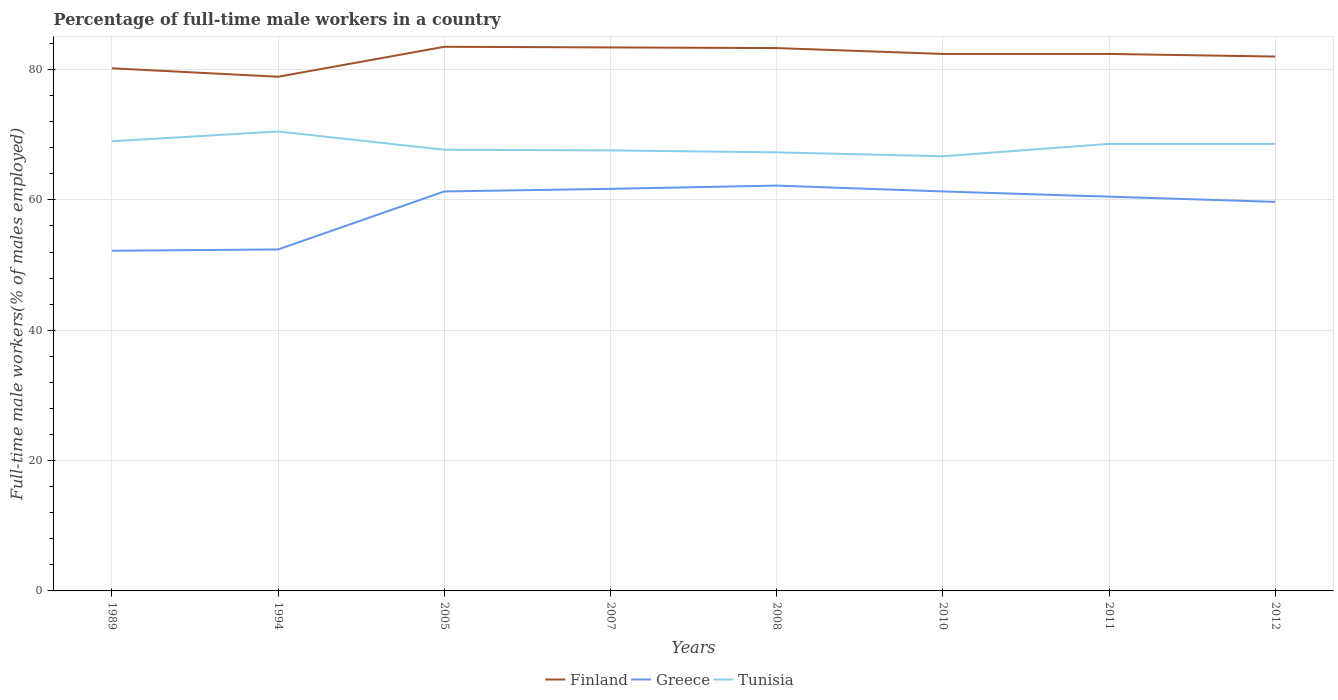Is the number of lines equal to the number of legend labels?
Your answer should be compact. Yes. Across all years, what is the maximum percentage of full-time male workers in Finland?
Give a very brief answer. 78.9. In which year was the percentage of full-time male workers in Tunisia maximum?
Offer a very short reply. 2010. What is the total percentage of full-time male workers in Greece in the graph?
Your answer should be very brief. 0. What is the difference between the highest and the second highest percentage of full-time male workers in Tunisia?
Make the answer very short. 3.8. What is the difference between the highest and the lowest percentage of full-time male workers in Finland?
Provide a succinct answer. 5. How many lines are there?
Ensure brevity in your answer.  3. Are the values on the major ticks of Y-axis written in scientific E-notation?
Offer a terse response. No. Does the graph contain grids?
Make the answer very short. Yes. How many legend labels are there?
Provide a succinct answer. 3. What is the title of the graph?
Your response must be concise. Percentage of full-time male workers in a country. What is the label or title of the Y-axis?
Offer a terse response. Full-time male workers(% of males employed). What is the Full-time male workers(% of males employed) in Finland in 1989?
Provide a succinct answer. 80.2. What is the Full-time male workers(% of males employed) of Greece in 1989?
Your answer should be compact. 52.2. What is the Full-time male workers(% of males employed) of Tunisia in 1989?
Provide a short and direct response. 69. What is the Full-time male workers(% of males employed) of Finland in 1994?
Keep it short and to the point. 78.9. What is the Full-time male workers(% of males employed) of Greece in 1994?
Ensure brevity in your answer.  52.4. What is the Full-time male workers(% of males employed) in Tunisia in 1994?
Ensure brevity in your answer.  70.5. What is the Full-time male workers(% of males employed) in Finland in 2005?
Your response must be concise. 83.5. What is the Full-time male workers(% of males employed) in Greece in 2005?
Provide a short and direct response. 61.3. What is the Full-time male workers(% of males employed) of Tunisia in 2005?
Your answer should be very brief. 67.7. What is the Full-time male workers(% of males employed) in Finland in 2007?
Your answer should be compact. 83.4. What is the Full-time male workers(% of males employed) in Greece in 2007?
Offer a terse response. 61.7. What is the Full-time male workers(% of males employed) in Tunisia in 2007?
Offer a very short reply. 67.6. What is the Full-time male workers(% of males employed) in Finland in 2008?
Ensure brevity in your answer.  83.3. What is the Full-time male workers(% of males employed) in Greece in 2008?
Offer a terse response. 62.2. What is the Full-time male workers(% of males employed) of Tunisia in 2008?
Ensure brevity in your answer.  67.3. What is the Full-time male workers(% of males employed) of Finland in 2010?
Give a very brief answer. 82.4. What is the Full-time male workers(% of males employed) in Greece in 2010?
Your response must be concise. 61.3. What is the Full-time male workers(% of males employed) of Tunisia in 2010?
Provide a short and direct response. 66.7. What is the Full-time male workers(% of males employed) in Finland in 2011?
Your response must be concise. 82.4. What is the Full-time male workers(% of males employed) in Greece in 2011?
Keep it short and to the point. 60.5. What is the Full-time male workers(% of males employed) in Tunisia in 2011?
Keep it short and to the point. 68.6. What is the Full-time male workers(% of males employed) in Finland in 2012?
Your response must be concise. 82. What is the Full-time male workers(% of males employed) in Greece in 2012?
Ensure brevity in your answer.  59.7. What is the Full-time male workers(% of males employed) in Tunisia in 2012?
Make the answer very short. 68.6. Across all years, what is the maximum Full-time male workers(% of males employed) of Finland?
Offer a very short reply. 83.5. Across all years, what is the maximum Full-time male workers(% of males employed) of Greece?
Your response must be concise. 62.2. Across all years, what is the maximum Full-time male workers(% of males employed) in Tunisia?
Make the answer very short. 70.5. Across all years, what is the minimum Full-time male workers(% of males employed) in Finland?
Your response must be concise. 78.9. Across all years, what is the minimum Full-time male workers(% of males employed) in Greece?
Make the answer very short. 52.2. Across all years, what is the minimum Full-time male workers(% of males employed) of Tunisia?
Make the answer very short. 66.7. What is the total Full-time male workers(% of males employed) of Finland in the graph?
Your answer should be very brief. 656.1. What is the total Full-time male workers(% of males employed) of Greece in the graph?
Keep it short and to the point. 471.3. What is the total Full-time male workers(% of males employed) of Tunisia in the graph?
Your answer should be very brief. 546. What is the difference between the Full-time male workers(% of males employed) of Finland in 1989 and that in 1994?
Provide a succinct answer. 1.3. What is the difference between the Full-time male workers(% of males employed) in Greece in 1989 and that in 1994?
Give a very brief answer. -0.2. What is the difference between the Full-time male workers(% of males employed) of Tunisia in 1989 and that in 1994?
Provide a short and direct response. -1.5. What is the difference between the Full-time male workers(% of males employed) in Finland in 1989 and that in 2005?
Ensure brevity in your answer.  -3.3. What is the difference between the Full-time male workers(% of males employed) of Finland in 1989 and that in 2007?
Make the answer very short. -3.2. What is the difference between the Full-time male workers(% of males employed) of Greece in 1989 and that in 2007?
Keep it short and to the point. -9.5. What is the difference between the Full-time male workers(% of males employed) in Tunisia in 1989 and that in 2007?
Provide a short and direct response. 1.4. What is the difference between the Full-time male workers(% of males employed) of Tunisia in 1989 and that in 2008?
Provide a succinct answer. 1.7. What is the difference between the Full-time male workers(% of males employed) in Tunisia in 1989 and that in 2010?
Your answer should be very brief. 2.3. What is the difference between the Full-time male workers(% of males employed) in Finland in 1989 and that in 2011?
Offer a very short reply. -2.2. What is the difference between the Full-time male workers(% of males employed) of Greece in 1989 and that in 2011?
Your answer should be very brief. -8.3. What is the difference between the Full-time male workers(% of males employed) in Greece in 1989 and that in 2012?
Your answer should be very brief. -7.5. What is the difference between the Full-time male workers(% of males employed) in Tunisia in 1994 and that in 2005?
Offer a very short reply. 2.8. What is the difference between the Full-time male workers(% of males employed) in Finland in 1994 and that in 2007?
Your answer should be compact. -4.5. What is the difference between the Full-time male workers(% of males employed) of Greece in 1994 and that in 2007?
Keep it short and to the point. -9.3. What is the difference between the Full-time male workers(% of males employed) in Tunisia in 1994 and that in 2007?
Ensure brevity in your answer.  2.9. What is the difference between the Full-time male workers(% of males employed) in Greece in 1994 and that in 2008?
Provide a short and direct response. -9.8. What is the difference between the Full-time male workers(% of males employed) in Tunisia in 1994 and that in 2008?
Offer a terse response. 3.2. What is the difference between the Full-time male workers(% of males employed) in Finland in 1994 and that in 2010?
Provide a short and direct response. -3.5. What is the difference between the Full-time male workers(% of males employed) of Greece in 1994 and that in 2010?
Provide a short and direct response. -8.9. What is the difference between the Full-time male workers(% of males employed) of Finland in 1994 and that in 2011?
Provide a succinct answer. -3.5. What is the difference between the Full-time male workers(% of males employed) in Greece in 1994 and that in 2011?
Offer a very short reply. -8.1. What is the difference between the Full-time male workers(% of males employed) in Tunisia in 1994 and that in 2011?
Provide a succinct answer. 1.9. What is the difference between the Full-time male workers(% of males employed) in Tunisia in 1994 and that in 2012?
Offer a terse response. 1.9. What is the difference between the Full-time male workers(% of males employed) in Finland in 2005 and that in 2008?
Offer a very short reply. 0.2. What is the difference between the Full-time male workers(% of males employed) of Tunisia in 2005 and that in 2008?
Ensure brevity in your answer.  0.4. What is the difference between the Full-time male workers(% of males employed) in Tunisia in 2005 and that in 2010?
Offer a terse response. 1. What is the difference between the Full-time male workers(% of males employed) of Finland in 2005 and that in 2011?
Keep it short and to the point. 1.1. What is the difference between the Full-time male workers(% of males employed) of Tunisia in 2005 and that in 2011?
Ensure brevity in your answer.  -0.9. What is the difference between the Full-time male workers(% of males employed) in Finland in 2005 and that in 2012?
Give a very brief answer. 1.5. What is the difference between the Full-time male workers(% of males employed) in Finland in 2007 and that in 2008?
Keep it short and to the point. 0.1. What is the difference between the Full-time male workers(% of males employed) of Greece in 2007 and that in 2008?
Make the answer very short. -0.5. What is the difference between the Full-time male workers(% of males employed) of Tunisia in 2007 and that in 2010?
Your answer should be compact. 0.9. What is the difference between the Full-time male workers(% of males employed) of Finland in 2007 and that in 2011?
Your answer should be very brief. 1. What is the difference between the Full-time male workers(% of males employed) of Finland in 2007 and that in 2012?
Your response must be concise. 1.4. What is the difference between the Full-time male workers(% of males employed) of Finland in 2008 and that in 2010?
Provide a short and direct response. 0.9. What is the difference between the Full-time male workers(% of males employed) of Tunisia in 2008 and that in 2010?
Your response must be concise. 0.6. What is the difference between the Full-time male workers(% of males employed) in Greece in 2008 and that in 2011?
Offer a terse response. 1.7. What is the difference between the Full-time male workers(% of males employed) of Finland in 2008 and that in 2012?
Make the answer very short. 1.3. What is the difference between the Full-time male workers(% of males employed) of Greece in 2008 and that in 2012?
Your response must be concise. 2.5. What is the difference between the Full-time male workers(% of males employed) of Tunisia in 2008 and that in 2012?
Make the answer very short. -1.3. What is the difference between the Full-time male workers(% of males employed) in Greece in 2010 and that in 2011?
Provide a succinct answer. 0.8. What is the difference between the Full-time male workers(% of males employed) in Tunisia in 2010 and that in 2011?
Your answer should be very brief. -1.9. What is the difference between the Full-time male workers(% of males employed) in Finland in 2010 and that in 2012?
Your answer should be compact. 0.4. What is the difference between the Full-time male workers(% of males employed) of Greece in 2010 and that in 2012?
Your answer should be compact. 1.6. What is the difference between the Full-time male workers(% of males employed) of Finland in 2011 and that in 2012?
Provide a succinct answer. 0.4. What is the difference between the Full-time male workers(% of males employed) in Tunisia in 2011 and that in 2012?
Offer a very short reply. 0. What is the difference between the Full-time male workers(% of males employed) of Finland in 1989 and the Full-time male workers(% of males employed) of Greece in 1994?
Your answer should be very brief. 27.8. What is the difference between the Full-time male workers(% of males employed) in Finland in 1989 and the Full-time male workers(% of males employed) in Tunisia in 1994?
Ensure brevity in your answer.  9.7. What is the difference between the Full-time male workers(% of males employed) in Greece in 1989 and the Full-time male workers(% of males employed) in Tunisia in 1994?
Keep it short and to the point. -18.3. What is the difference between the Full-time male workers(% of males employed) in Greece in 1989 and the Full-time male workers(% of males employed) in Tunisia in 2005?
Make the answer very short. -15.5. What is the difference between the Full-time male workers(% of males employed) in Finland in 1989 and the Full-time male workers(% of males employed) in Greece in 2007?
Your answer should be compact. 18.5. What is the difference between the Full-time male workers(% of males employed) of Finland in 1989 and the Full-time male workers(% of males employed) of Tunisia in 2007?
Your answer should be compact. 12.6. What is the difference between the Full-time male workers(% of males employed) of Greece in 1989 and the Full-time male workers(% of males employed) of Tunisia in 2007?
Your answer should be compact. -15.4. What is the difference between the Full-time male workers(% of males employed) of Greece in 1989 and the Full-time male workers(% of males employed) of Tunisia in 2008?
Offer a terse response. -15.1. What is the difference between the Full-time male workers(% of males employed) of Finland in 1989 and the Full-time male workers(% of males employed) of Greece in 2010?
Your answer should be compact. 18.9. What is the difference between the Full-time male workers(% of males employed) in Finland in 1989 and the Full-time male workers(% of males employed) in Tunisia in 2010?
Provide a succinct answer. 13.5. What is the difference between the Full-time male workers(% of males employed) in Greece in 1989 and the Full-time male workers(% of males employed) in Tunisia in 2010?
Your answer should be very brief. -14.5. What is the difference between the Full-time male workers(% of males employed) in Finland in 1989 and the Full-time male workers(% of males employed) in Greece in 2011?
Give a very brief answer. 19.7. What is the difference between the Full-time male workers(% of males employed) of Greece in 1989 and the Full-time male workers(% of males employed) of Tunisia in 2011?
Your response must be concise. -16.4. What is the difference between the Full-time male workers(% of males employed) of Finland in 1989 and the Full-time male workers(% of males employed) of Greece in 2012?
Offer a terse response. 20.5. What is the difference between the Full-time male workers(% of males employed) of Greece in 1989 and the Full-time male workers(% of males employed) of Tunisia in 2012?
Provide a succinct answer. -16.4. What is the difference between the Full-time male workers(% of males employed) of Greece in 1994 and the Full-time male workers(% of males employed) of Tunisia in 2005?
Your answer should be compact. -15.3. What is the difference between the Full-time male workers(% of males employed) of Finland in 1994 and the Full-time male workers(% of males employed) of Greece in 2007?
Your answer should be compact. 17.2. What is the difference between the Full-time male workers(% of males employed) in Finland in 1994 and the Full-time male workers(% of males employed) in Tunisia in 2007?
Offer a very short reply. 11.3. What is the difference between the Full-time male workers(% of males employed) of Greece in 1994 and the Full-time male workers(% of males employed) of Tunisia in 2007?
Offer a very short reply. -15.2. What is the difference between the Full-time male workers(% of males employed) in Finland in 1994 and the Full-time male workers(% of males employed) in Greece in 2008?
Your answer should be compact. 16.7. What is the difference between the Full-time male workers(% of males employed) of Finland in 1994 and the Full-time male workers(% of males employed) of Tunisia in 2008?
Offer a terse response. 11.6. What is the difference between the Full-time male workers(% of males employed) of Greece in 1994 and the Full-time male workers(% of males employed) of Tunisia in 2008?
Your response must be concise. -14.9. What is the difference between the Full-time male workers(% of males employed) of Finland in 1994 and the Full-time male workers(% of males employed) of Greece in 2010?
Provide a succinct answer. 17.6. What is the difference between the Full-time male workers(% of males employed) in Finland in 1994 and the Full-time male workers(% of males employed) in Tunisia in 2010?
Provide a succinct answer. 12.2. What is the difference between the Full-time male workers(% of males employed) of Greece in 1994 and the Full-time male workers(% of males employed) of Tunisia in 2010?
Offer a very short reply. -14.3. What is the difference between the Full-time male workers(% of males employed) in Finland in 1994 and the Full-time male workers(% of males employed) in Greece in 2011?
Provide a short and direct response. 18.4. What is the difference between the Full-time male workers(% of males employed) of Finland in 1994 and the Full-time male workers(% of males employed) of Tunisia in 2011?
Keep it short and to the point. 10.3. What is the difference between the Full-time male workers(% of males employed) of Greece in 1994 and the Full-time male workers(% of males employed) of Tunisia in 2011?
Offer a very short reply. -16.2. What is the difference between the Full-time male workers(% of males employed) in Greece in 1994 and the Full-time male workers(% of males employed) in Tunisia in 2012?
Your answer should be compact. -16.2. What is the difference between the Full-time male workers(% of males employed) in Finland in 2005 and the Full-time male workers(% of males employed) in Greece in 2007?
Provide a short and direct response. 21.8. What is the difference between the Full-time male workers(% of males employed) of Greece in 2005 and the Full-time male workers(% of males employed) of Tunisia in 2007?
Offer a very short reply. -6.3. What is the difference between the Full-time male workers(% of males employed) in Finland in 2005 and the Full-time male workers(% of males employed) in Greece in 2008?
Keep it short and to the point. 21.3. What is the difference between the Full-time male workers(% of males employed) of Greece in 2005 and the Full-time male workers(% of males employed) of Tunisia in 2008?
Keep it short and to the point. -6. What is the difference between the Full-time male workers(% of males employed) in Finland in 2005 and the Full-time male workers(% of males employed) in Tunisia in 2010?
Keep it short and to the point. 16.8. What is the difference between the Full-time male workers(% of males employed) in Greece in 2005 and the Full-time male workers(% of males employed) in Tunisia in 2010?
Give a very brief answer. -5.4. What is the difference between the Full-time male workers(% of males employed) in Finland in 2005 and the Full-time male workers(% of males employed) in Tunisia in 2011?
Your response must be concise. 14.9. What is the difference between the Full-time male workers(% of males employed) of Finland in 2005 and the Full-time male workers(% of males employed) of Greece in 2012?
Keep it short and to the point. 23.8. What is the difference between the Full-time male workers(% of males employed) in Finland in 2005 and the Full-time male workers(% of males employed) in Tunisia in 2012?
Offer a terse response. 14.9. What is the difference between the Full-time male workers(% of males employed) of Finland in 2007 and the Full-time male workers(% of males employed) of Greece in 2008?
Keep it short and to the point. 21.2. What is the difference between the Full-time male workers(% of males employed) in Greece in 2007 and the Full-time male workers(% of males employed) in Tunisia in 2008?
Give a very brief answer. -5.6. What is the difference between the Full-time male workers(% of males employed) of Finland in 2007 and the Full-time male workers(% of males employed) of Greece in 2010?
Offer a very short reply. 22.1. What is the difference between the Full-time male workers(% of males employed) of Finland in 2007 and the Full-time male workers(% of males employed) of Tunisia in 2010?
Your answer should be very brief. 16.7. What is the difference between the Full-time male workers(% of males employed) in Greece in 2007 and the Full-time male workers(% of males employed) in Tunisia in 2010?
Offer a terse response. -5. What is the difference between the Full-time male workers(% of males employed) in Finland in 2007 and the Full-time male workers(% of males employed) in Greece in 2011?
Make the answer very short. 22.9. What is the difference between the Full-time male workers(% of males employed) of Finland in 2007 and the Full-time male workers(% of males employed) of Greece in 2012?
Offer a very short reply. 23.7. What is the difference between the Full-time male workers(% of males employed) in Finland in 2007 and the Full-time male workers(% of males employed) in Tunisia in 2012?
Offer a very short reply. 14.8. What is the difference between the Full-time male workers(% of males employed) in Greece in 2007 and the Full-time male workers(% of males employed) in Tunisia in 2012?
Make the answer very short. -6.9. What is the difference between the Full-time male workers(% of males employed) of Greece in 2008 and the Full-time male workers(% of males employed) of Tunisia in 2010?
Give a very brief answer. -4.5. What is the difference between the Full-time male workers(% of males employed) of Finland in 2008 and the Full-time male workers(% of males employed) of Greece in 2011?
Offer a very short reply. 22.8. What is the difference between the Full-time male workers(% of males employed) of Finland in 2008 and the Full-time male workers(% of males employed) of Greece in 2012?
Your answer should be very brief. 23.6. What is the difference between the Full-time male workers(% of males employed) of Greece in 2008 and the Full-time male workers(% of males employed) of Tunisia in 2012?
Make the answer very short. -6.4. What is the difference between the Full-time male workers(% of males employed) in Finland in 2010 and the Full-time male workers(% of males employed) in Greece in 2011?
Provide a succinct answer. 21.9. What is the difference between the Full-time male workers(% of males employed) of Finland in 2010 and the Full-time male workers(% of males employed) of Greece in 2012?
Provide a succinct answer. 22.7. What is the difference between the Full-time male workers(% of males employed) in Greece in 2010 and the Full-time male workers(% of males employed) in Tunisia in 2012?
Your response must be concise. -7.3. What is the difference between the Full-time male workers(% of males employed) of Finland in 2011 and the Full-time male workers(% of males employed) of Greece in 2012?
Your answer should be very brief. 22.7. What is the difference between the Full-time male workers(% of males employed) in Finland in 2011 and the Full-time male workers(% of males employed) in Tunisia in 2012?
Provide a succinct answer. 13.8. What is the average Full-time male workers(% of males employed) in Finland per year?
Keep it short and to the point. 82.01. What is the average Full-time male workers(% of males employed) in Greece per year?
Provide a succinct answer. 58.91. What is the average Full-time male workers(% of males employed) in Tunisia per year?
Make the answer very short. 68.25. In the year 1989, what is the difference between the Full-time male workers(% of males employed) of Greece and Full-time male workers(% of males employed) of Tunisia?
Offer a terse response. -16.8. In the year 1994, what is the difference between the Full-time male workers(% of males employed) in Finland and Full-time male workers(% of males employed) in Greece?
Provide a succinct answer. 26.5. In the year 1994, what is the difference between the Full-time male workers(% of males employed) of Greece and Full-time male workers(% of males employed) of Tunisia?
Your response must be concise. -18.1. In the year 2005, what is the difference between the Full-time male workers(% of males employed) of Finland and Full-time male workers(% of males employed) of Greece?
Your response must be concise. 22.2. In the year 2007, what is the difference between the Full-time male workers(% of males employed) in Finland and Full-time male workers(% of males employed) in Greece?
Offer a very short reply. 21.7. In the year 2007, what is the difference between the Full-time male workers(% of males employed) of Greece and Full-time male workers(% of males employed) of Tunisia?
Provide a short and direct response. -5.9. In the year 2008, what is the difference between the Full-time male workers(% of males employed) of Finland and Full-time male workers(% of males employed) of Greece?
Your response must be concise. 21.1. In the year 2008, what is the difference between the Full-time male workers(% of males employed) of Finland and Full-time male workers(% of males employed) of Tunisia?
Give a very brief answer. 16. In the year 2008, what is the difference between the Full-time male workers(% of males employed) of Greece and Full-time male workers(% of males employed) of Tunisia?
Your answer should be very brief. -5.1. In the year 2010, what is the difference between the Full-time male workers(% of males employed) of Finland and Full-time male workers(% of males employed) of Greece?
Provide a short and direct response. 21.1. In the year 2010, what is the difference between the Full-time male workers(% of males employed) of Finland and Full-time male workers(% of males employed) of Tunisia?
Give a very brief answer. 15.7. In the year 2010, what is the difference between the Full-time male workers(% of males employed) in Greece and Full-time male workers(% of males employed) in Tunisia?
Your answer should be very brief. -5.4. In the year 2011, what is the difference between the Full-time male workers(% of males employed) in Finland and Full-time male workers(% of males employed) in Greece?
Ensure brevity in your answer.  21.9. In the year 2012, what is the difference between the Full-time male workers(% of males employed) in Finland and Full-time male workers(% of males employed) in Greece?
Offer a terse response. 22.3. In the year 2012, what is the difference between the Full-time male workers(% of males employed) in Finland and Full-time male workers(% of males employed) in Tunisia?
Keep it short and to the point. 13.4. In the year 2012, what is the difference between the Full-time male workers(% of males employed) in Greece and Full-time male workers(% of males employed) in Tunisia?
Ensure brevity in your answer.  -8.9. What is the ratio of the Full-time male workers(% of males employed) of Finland in 1989 to that in 1994?
Offer a very short reply. 1.02. What is the ratio of the Full-time male workers(% of males employed) in Tunisia in 1989 to that in 1994?
Your answer should be compact. 0.98. What is the ratio of the Full-time male workers(% of males employed) in Finland in 1989 to that in 2005?
Provide a short and direct response. 0.96. What is the ratio of the Full-time male workers(% of males employed) in Greece in 1989 to that in 2005?
Offer a very short reply. 0.85. What is the ratio of the Full-time male workers(% of males employed) of Tunisia in 1989 to that in 2005?
Give a very brief answer. 1.02. What is the ratio of the Full-time male workers(% of males employed) in Finland in 1989 to that in 2007?
Offer a very short reply. 0.96. What is the ratio of the Full-time male workers(% of males employed) of Greece in 1989 to that in 2007?
Offer a very short reply. 0.85. What is the ratio of the Full-time male workers(% of males employed) of Tunisia in 1989 to that in 2007?
Provide a succinct answer. 1.02. What is the ratio of the Full-time male workers(% of males employed) of Finland in 1989 to that in 2008?
Make the answer very short. 0.96. What is the ratio of the Full-time male workers(% of males employed) of Greece in 1989 to that in 2008?
Keep it short and to the point. 0.84. What is the ratio of the Full-time male workers(% of males employed) of Tunisia in 1989 to that in 2008?
Your answer should be very brief. 1.03. What is the ratio of the Full-time male workers(% of males employed) in Finland in 1989 to that in 2010?
Your answer should be very brief. 0.97. What is the ratio of the Full-time male workers(% of males employed) in Greece in 1989 to that in 2010?
Your answer should be compact. 0.85. What is the ratio of the Full-time male workers(% of males employed) of Tunisia in 1989 to that in 2010?
Your response must be concise. 1.03. What is the ratio of the Full-time male workers(% of males employed) of Finland in 1989 to that in 2011?
Make the answer very short. 0.97. What is the ratio of the Full-time male workers(% of males employed) in Greece in 1989 to that in 2011?
Keep it short and to the point. 0.86. What is the ratio of the Full-time male workers(% of males employed) of Greece in 1989 to that in 2012?
Give a very brief answer. 0.87. What is the ratio of the Full-time male workers(% of males employed) of Tunisia in 1989 to that in 2012?
Provide a short and direct response. 1.01. What is the ratio of the Full-time male workers(% of males employed) of Finland in 1994 to that in 2005?
Offer a terse response. 0.94. What is the ratio of the Full-time male workers(% of males employed) of Greece in 1994 to that in 2005?
Offer a very short reply. 0.85. What is the ratio of the Full-time male workers(% of males employed) in Tunisia in 1994 to that in 2005?
Make the answer very short. 1.04. What is the ratio of the Full-time male workers(% of males employed) of Finland in 1994 to that in 2007?
Your answer should be very brief. 0.95. What is the ratio of the Full-time male workers(% of males employed) in Greece in 1994 to that in 2007?
Provide a short and direct response. 0.85. What is the ratio of the Full-time male workers(% of males employed) in Tunisia in 1994 to that in 2007?
Provide a succinct answer. 1.04. What is the ratio of the Full-time male workers(% of males employed) of Finland in 1994 to that in 2008?
Keep it short and to the point. 0.95. What is the ratio of the Full-time male workers(% of males employed) in Greece in 1994 to that in 2008?
Your response must be concise. 0.84. What is the ratio of the Full-time male workers(% of males employed) in Tunisia in 1994 to that in 2008?
Offer a very short reply. 1.05. What is the ratio of the Full-time male workers(% of males employed) in Finland in 1994 to that in 2010?
Keep it short and to the point. 0.96. What is the ratio of the Full-time male workers(% of males employed) in Greece in 1994 to that in 2010?
Offer a terse response. 0.85. What is the ratio of the Full-time male workers(% of males employed) in Tunisia in 1994 to that in 2010?
Offer a very short reply. 1.06. What is the ratio of the Full-time male workers(% of males employed) of Finland in 1994 to that in 2011?
Your answer should be very brief. 0.96. What is the ratio of the Full-time male workers(% of males employed) of Greece in 1994 to that in 2011?
Provide a succinct answer. 0.87. What is the ratio of the Full-time male workers(% of males employed) of Tunisia in 1994 to that in 2011?
Make the answer very short. 1.03. What is the ratio of the Full-time male workers(% of males employed) of Finland in 1994 to that in 2012?
Keep it short and to the point. 0.96. What is the ratio of the Full-time male workers(% of males employed) of Greece in 1994 to that in 2012?
Your answer should be compact. 0.88. What is the ratio of the Full-time male workers(% of males employed) of Tunisia in 1994 to that in 2012?
Ensure brevity in your answer.  1.03. What is the ratio of the Full-time male workers(% of males employed) of Greece in 2005 to that in 2007?
Make the answer very short. 0.99. What is the ratio of the Full-time male workers(% of males employed) of Greece in 2005 to that in 2008?
Offer a terse response. 0.99. What is the ratio of the Full-time male workers(% of males employed) in Tunisia in 2005 to that in 2008?
Offer a terse response. 1.01. What is the ratio of the Full-time male workers(% of males employed) of Finland in 2005 to that in 2010?
Your answer should be compact. 1.01. What is the ratio of the Full-time male workers(% of males employed) of Greece in 2005 to that in 2010?
Make the answer very short. 1. What is the ratio of the Full-time male workers(% of males employed) of Finland in 2005 to that in 2011?
Give a very brief answer. 1.01. What is the ratio of the Full-time male workers(% of males employed) in Greece in 2005 to that in 2011?
Ensure brevity in your answer.  1.01. What is the ratio of the Full-time male workers(% of males employed) in Tunisia in 2005 to that in 2011?
Keep it short and to the point. 0.99. What is the ratio of the Full-time male workers(% of males employed) in Finland in 2005 to that in 2012?
Provide a short and direct response. 1.02. What is the ratio of the Full-time male workers(% of males employed) of Greece in 2005 to that in 2012?
Offer a very short reply. 1.03. What is the ratio of the Full-time male workers(% of males employed) of Tunisia in 2005 to that in 2012?
Offer a terse response. 0.99. What is the ratio of the Full-time male workers(% of males employed) of Greece in 2007 to that in 2008?
Ensure brevity in your answer.  0.99. What is the ratio of the Full-time male workers(% of males employed) in Tunisia in 2007 to that in 2008?
Keep it short and to the point. 1. What is the ratio of the Full-time male workers(% of males employed) of Finland in 2007 to that in 2010?
Your answer should be compact. 1.01. What is the ratio of the Full-time male workers(% of males employed) of Tunisia in 2007 to that in 2010?
Provide a succinct answer. 1.01. What is the ratio of the Full-time male workers(% of males employed) of Finland in 2007 to that in 2011?
Give a very brief answer. 1.01. What is the ratio of the Full-time male workers(% of males employed) in Greece in 2007 to that in 2011?
Offer a terse response. 1.02. What is the ratio of the Full-time male workers(% of males employed) of Tunisia in 2007 to that in 2011?
Keep it short and to the point. 0.99. What is the ratio of the Full-time male workers(% of males employed) of Finland in 2007 to that in 2012?
Provide a succinct answer. 1.02. What is the ratio of the Full-time male workers(% of males employed) in Greece in 2007 to that in 2012?
Offer a very short reply. 1.03. What is the ratio of the Full-time male workers(% of males employed) in Tunisia in 2007 to that in 2012?
Ensure brevity in your answer.  0.99. What is the ratio of the Full-time male workers(% of males employed) in Finland in 2008 to that in 2010?
Keep it short and to the point. 1.01. What is the ratio of the Full-time male workers(% of males employed) in Greece in 2008 to that in 2010?
Provide a short and direct response. 1.01. What is the ratio of the Full-time male workers(% of males employed) of Finland in 2008 to that in 2011?
Your answer should be very brief. 1.01. What is the ratio of the Full-time male workers(% of males employed) in Greece in 2008 to that in 2011?
Ensure brevity in your answer.  1.03. What is the ratio of the Full-time male workers(% of males employed) in Finland in 2008 to that in 2012?
Make the answer very short. 1.02. What is the ratio of the Full-time male workers(% of males employed) in Greece in 2008 to that in 2012?
Offer a terse response. 1.04. What is the ratio of the Full-time male workers(% of males employed) of Tunisia in 2008 to that in 2012?
Provide a short and direct response. 0.98. What is the ratio of the Full-time male workers(% of males employed) in Finland in 2010 to that in 2011?
Give a very brief answer. 1. What is the ratio of the Full-time male workers(% of males employed) in Greece in 2010 to that in 2011?
Provide a succinct answer. 1.01. What is the ratio of the Full-time male workers(% of males employed) of Tunisia in 2010 to that in 2011?
Your answer should be compact. 0.97. What is the ratio of the Full-time male workers(% of males employed) in Greece in 2010 to that in 2012?
Provide a short and direct response. 1.03. What is the ratio of the Full-time male workers(% of males employed) of Tunisia in 2010 to that in 2012?
Offer a very short reply. 0.97. What is the ratio of the Full-time male workers(% of males employed) in Finland in 2011 to that in 2012?
Your answer should be very brief. 1. What is the ratio of the Full-time male workers(% of males employed) in Greece in 2011 to that in 2012?
Keep it short and to the point. 1.01. What is the difference between the highest and the second highest Full-time male workers(% of males employed) in Finland?
Give a very brief answer. 0.1. What is the difference between the highest and the second highest Full-time male workers(% of males employed) in Greece?
Make the answer very short. 0.5. What is the difference between the highest and the second highest Full-time male workers(% of males employed) of Tunisia?
Ensure brevity in your answer.  1.5. What is the difference between the highest and the lowest Full-time male workers(% of males employed) of Greece?
Ensure brevity in your answer.  10. 